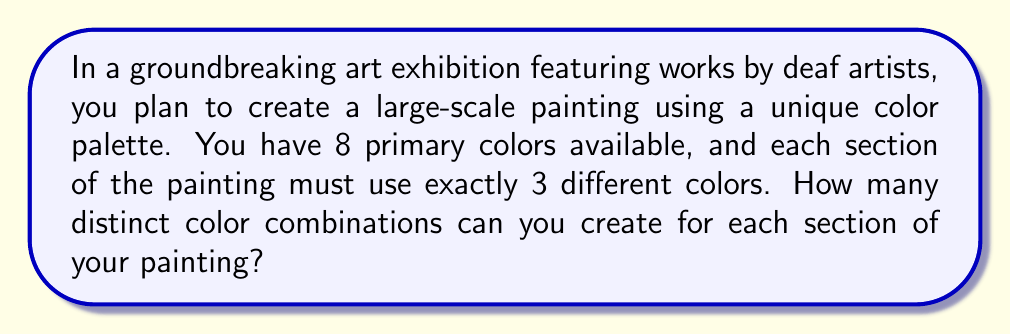Show me your answer to this math problem. Let's approach this step-by-step:

1) This is a combination problem. We need to select 3 colors out of 8 available colors, where the order doesn't matter (as we're just interested in which colors are used, not the order they're applied).

2) The formula for combinations is:

   $$C(n,r) = \frac{n!}{r!(n-r)!}$$

   Where $n$ is the total number of items to choose from, and $r$ is the number of items being chosen.

3) In this case, $n = 8$ (total colors) and $r = 3$ (colors used in each section).

4) Plugging these values into our formula:

   $$C(8,3) = \frac{8!}{3!(8-3)!} = \frac{8!}{3!5!}$$

5) Expanding this:
   
   $$\frac{8 \cdot 7 \cdot 6 \cdot 5!}{(3 \cdot 2 \cdot 1) \cdot 5!}$$

6) The 5! cancels out in the numerator and denominator:

   $$\frac{8 \cdot 7 \cdot 6}{3 \cdot 2 \cdot 1} = \frac{336}{6} = 56$$

Therefore, there are 56 distinct color combinations possible for each section of the painting.
Answer: 56 